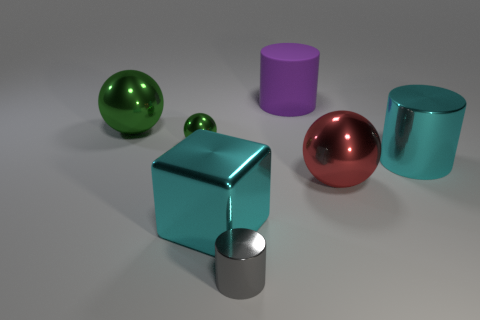Subtract all blue cylinders. Subtract all yellow balls. How many cylinders are left? 3 Add 2 small green spheres. How many objects exist? 9 Subtract all spheres. How many objects are left? 4 Subtract 0 green blocks. How many objects are left? 7 Subtract all red metal spheres. Subtract all gray metallic cylinders. How many objects are left? 5 Add 2 big purple cylinders. How many big purple cylinders are left? 3 Add 6 small green shiny balls. How many small green shiny balls exist? 7 